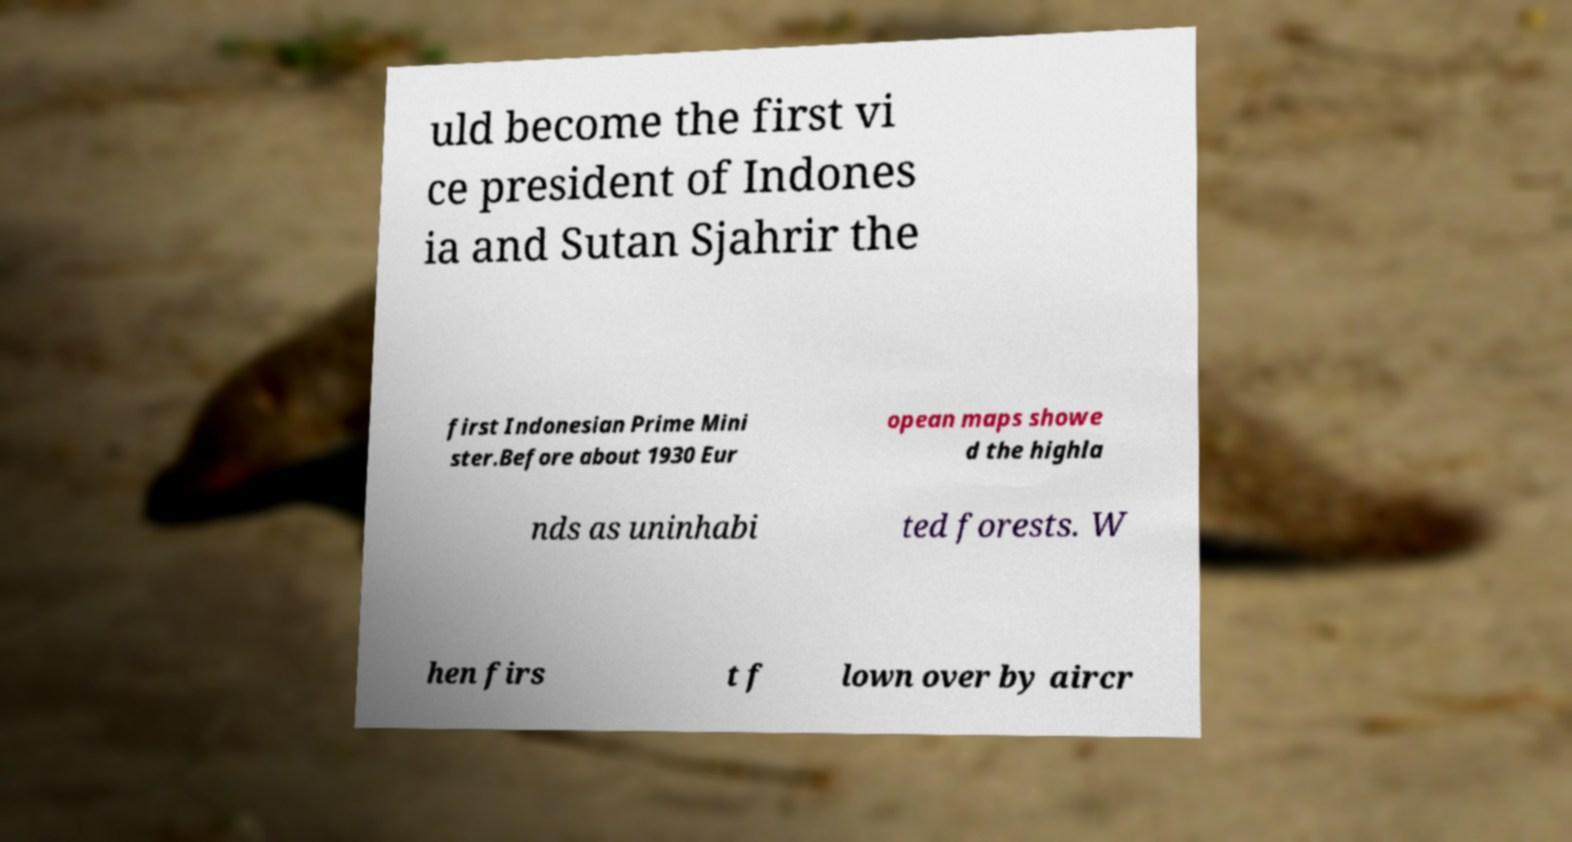I need the written content from this picture converted into text. Can you do that? uld become the first vi ce president of Indones ia and Sutan Sjahrir the first Indonesian Prime Mini ster.Before about 1930 Eur opean maps showe d the highla nds as uninhabi ted forests. W hen firs t f lown over by aircr 